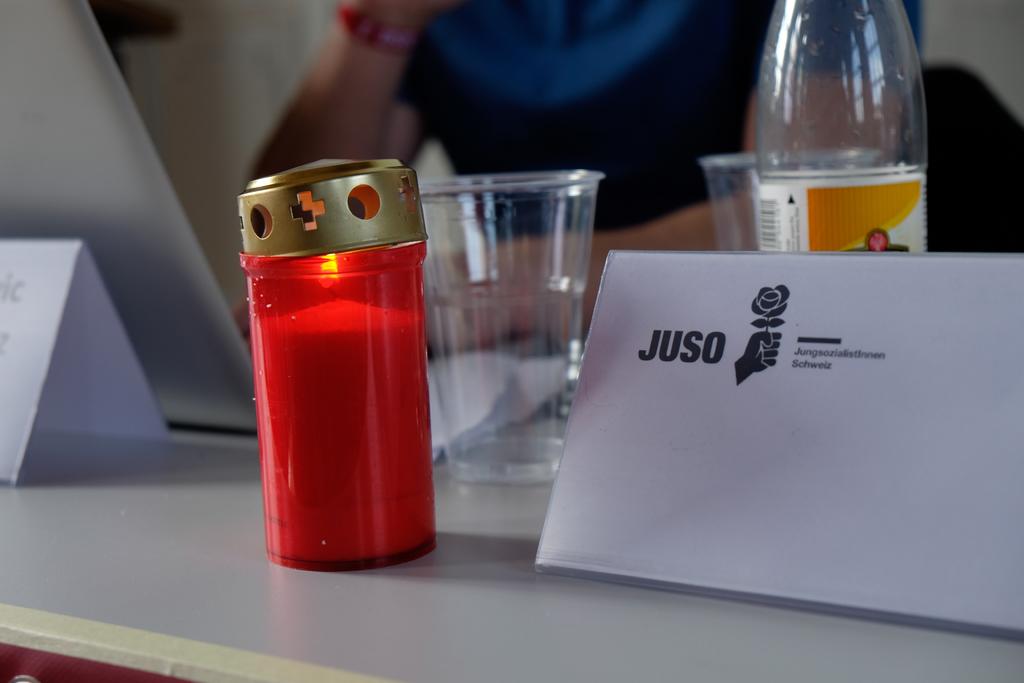What is the company name on the letter?
Ensure brevity in your answer.  Juso. 